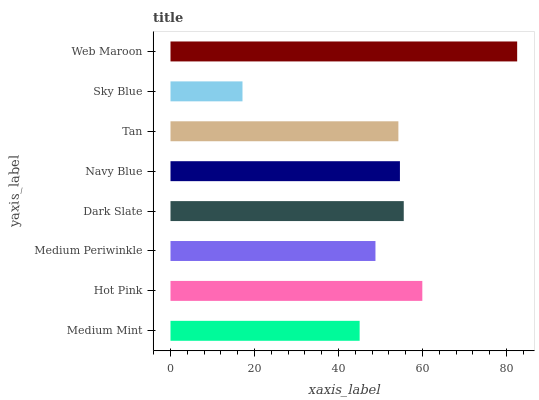Is Sky Blue the minimum?
Answer yes or no. Yes. Is Web Maroon the maximum?
Answer yes or no. Yes. Is Hot Pink the minimum?
Answer yes or no. No. Is Hot Pink the maximum?
Answer yes or no. No. Is Hot Pink greater than Medium Mint?
Answer yes or no. Yes. Is Medium Mint less than Hot Pink?
Answer yes or no. Yes. Is Medium Mint greater than Hot Pink?
Answer yes or no. No. Is Hot Pink less than Medium Mint?
Answer yes or no. No. Is Navy Blue the high median?
Answer yes or no. Yes. Is Tan the low median?
Answer yes or no. Yes. Is Sky Blue the high median?
Answer yes or no. No. Is Dark Slate the low median?
Answer yes or no. No. 